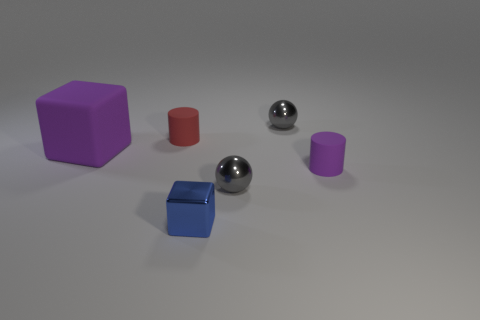Can you describe the lighting and shadows in the scene? Certainly! The lighting in the scene is soft and diffused, seemingly coming from a source above the objects as indicated by the soft shadows they cast. The shadows are not sharply defined, suggesting that the main light source is not extremely close to the objects. This setup gives the scene a calm and neutral atmosphere. Does the lighting tell us anything about the shape of the objects? Yes, the way light reflects and casts shadows allows us to perceive the dimensions and contours of the objects. For example, the spheres create crescent-shaped highlights, which emphasize their roundness. The cylinders cast elliptical shadows, hinting at their circular bases, while the shadows of the cubes help delineate their angular corners and flat surfaces. 